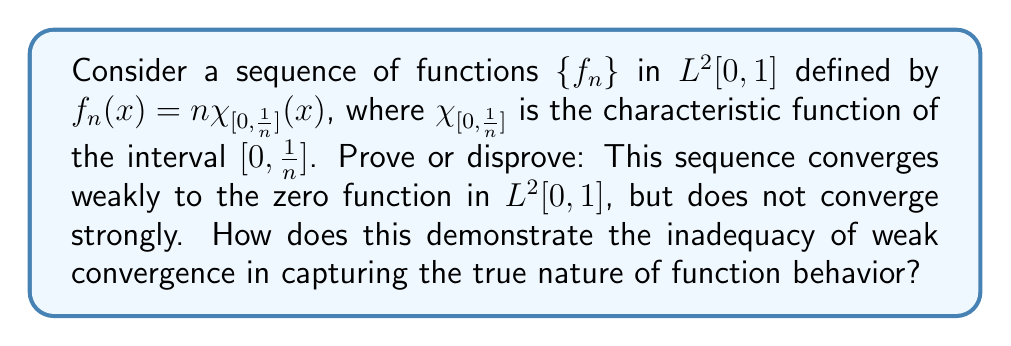Teach me how to tackle this problem. Let's approach this problem step-by-step:

1) First, let's check for weak convergence:
   For weak convergence, we need to show that $\langle f_n, g \rangle \to 0$ for all $g \in L^2[0,1]$.
   
   $$\langle f_n, g \rangle = \int_0^1 f_n(x)g(x)dx = n\int_0^{\frac{1}{n}} g(x)dx$$
   
   By the Cauchy-Schwarz inequality:
   
   $$|n\int_0^{\frac{1}{n}} g(x)dx| \leq n \cdot \frac{1}{\sqrt{n}} \cdot \|g\|_{L^2[0,1]} = \sqrt{n}\|g\|_{L^2[0,1]}$$
   
   As $n \to \infty$, this tends to zero. Thus, $f_n$ converges weakly to zero.

2) Now, let's check for strong convergence:
   For strong convergence, we need to show that $\|f_n - 0\|_{L^2[0,1]} \to 0$ as $n \to \infty$.
   
   $$\|f_n\|_{L^2[0,1]}^2 = \int_0^1 |f_n(x)|^2 dx = n^2 \int_0^{\frac{1}{n}} dx = n$$
   
   As $n \to \infty$, this diverges. Thus, $f_n$ does not converge strongly to zero.

3) This example demonstrates the inadequacy of weak convergence in capturing the true nature of function behavior because:

   a) The weak limit (zero function) fails to capture the increasingly concentrated nature of $f_n$ near $x=0$.
   
   b) The $L^2$ norm of $f_n$ is actually increasing, which is completely missed by weak convergence.
   
   c) Weak convergence only captures the average behavior of the function against all test functions, missing localized phenomena.

This discrepancy between weak and strong convergence highlights the limitations of weak convergence in fully describing the behavior of function sequences, especially when dealing with highly oscillatory or concentrated functions.
Answer: The sequence $\{f_n\}$ converges weakly to the zero function in $L^2[0,1]$, but does not converge strongly. This demonstrates that weak convergence fails to capture the concentrated behavior of $f_n$ near $x=0$ and misses the fact that the $L^2$ norm of $f_n$ is increasing, highlighting the inadequacy of weak convergence in fully describing function behavior. 